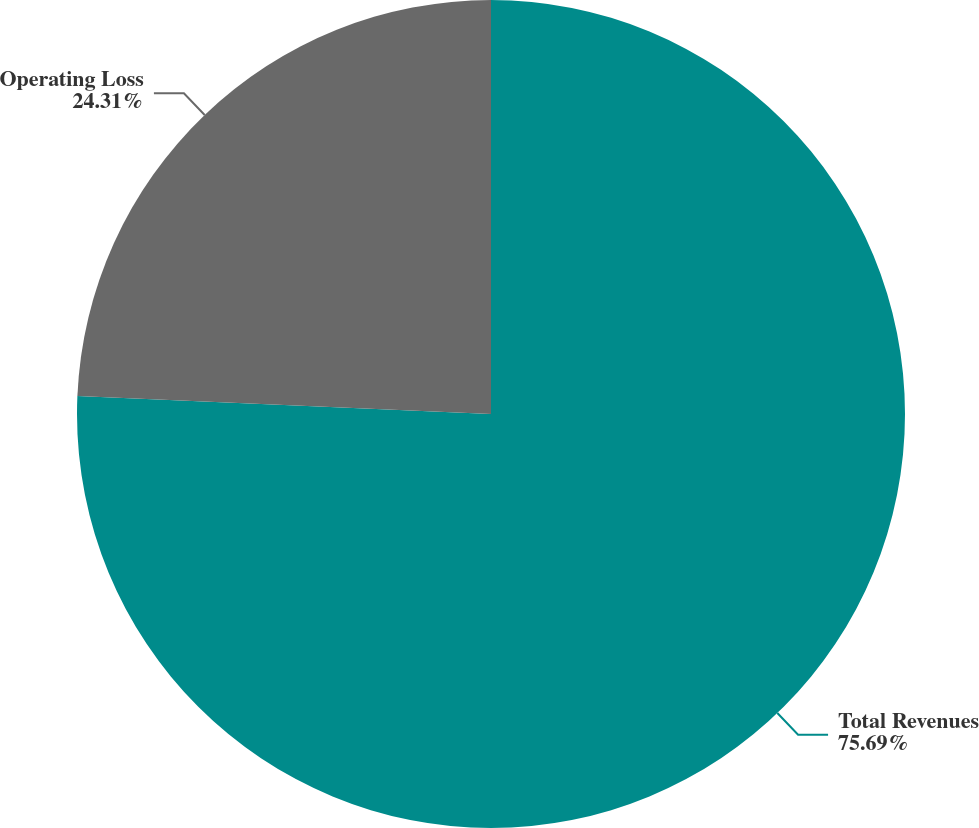<chart> <loc_0><loc_0><loc_500><loc_500><pie_chart><fcel>Total Revenues<fcel>Operating Loss<nl><fcel>75.69%<fcel>24.31%<nl></chart> 